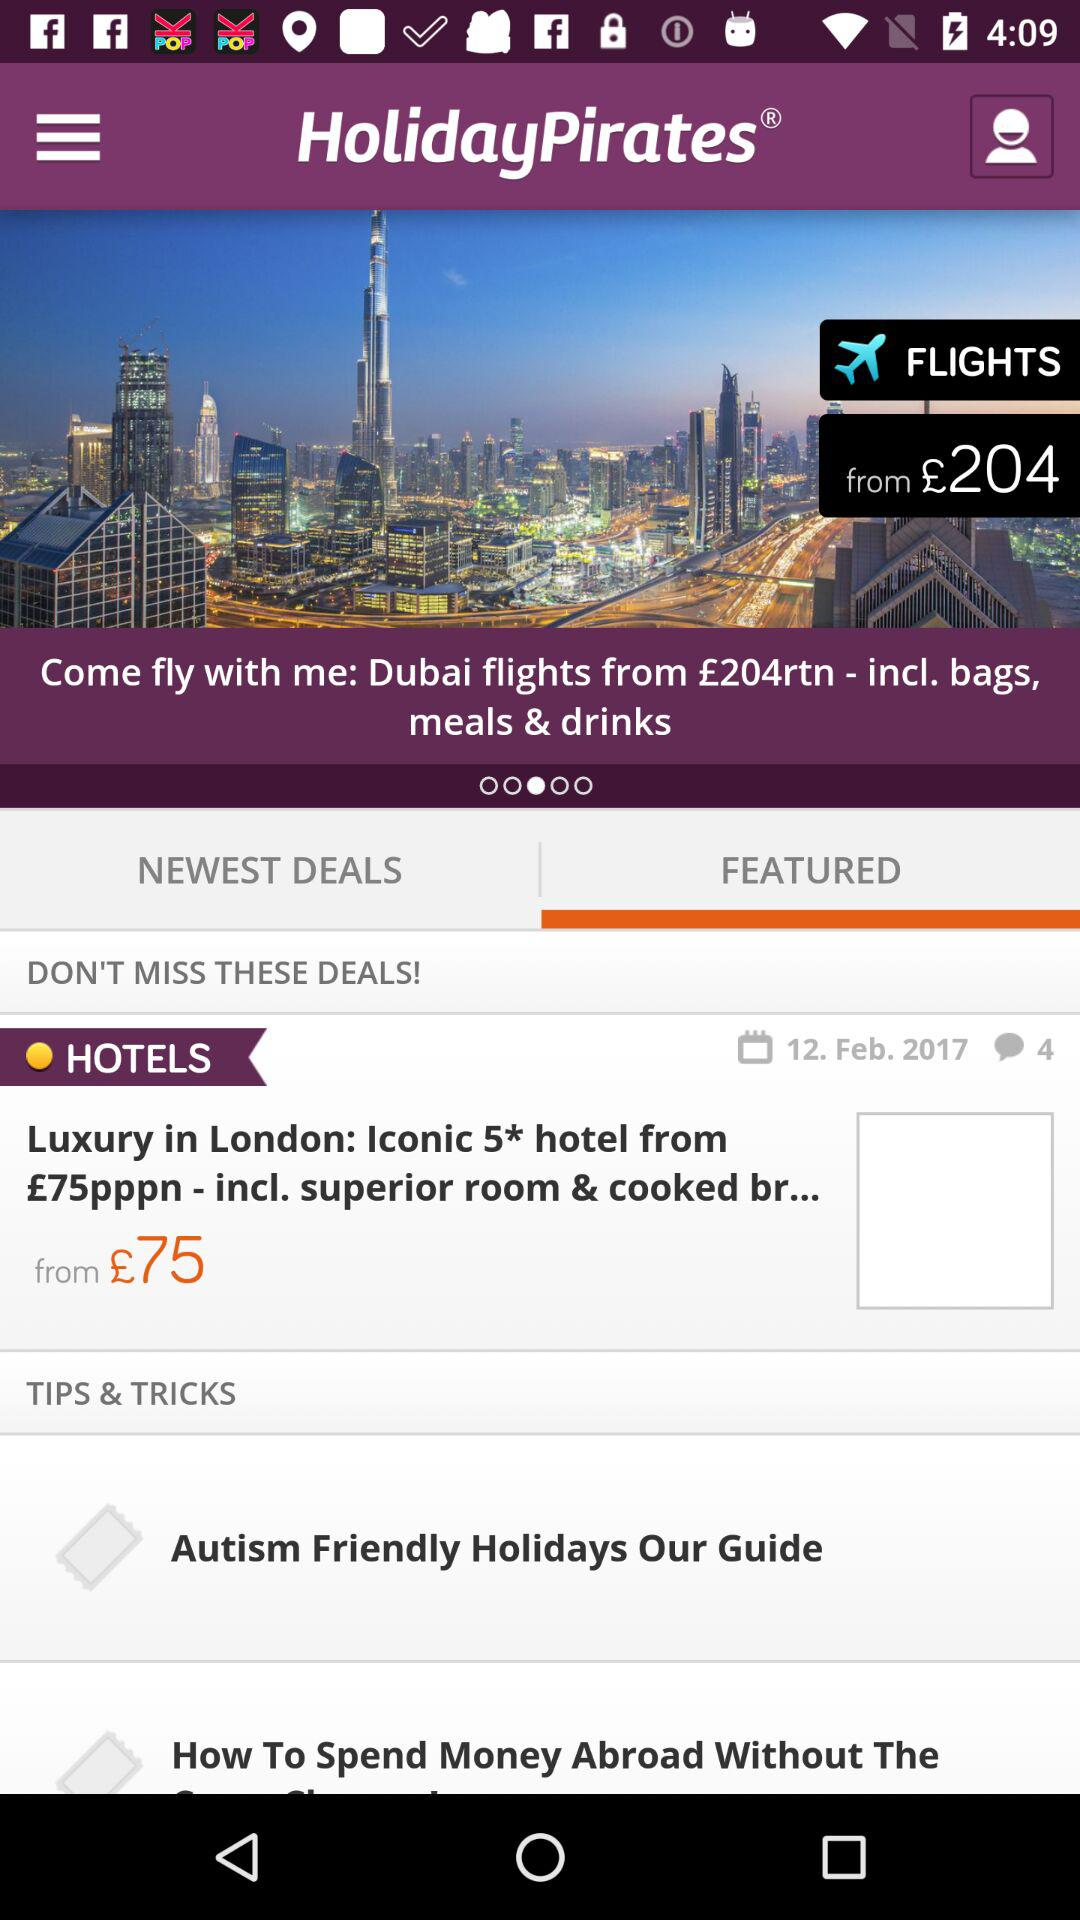What is the starting price of the hotel room? The starting price of the hotel room starts at £75. 